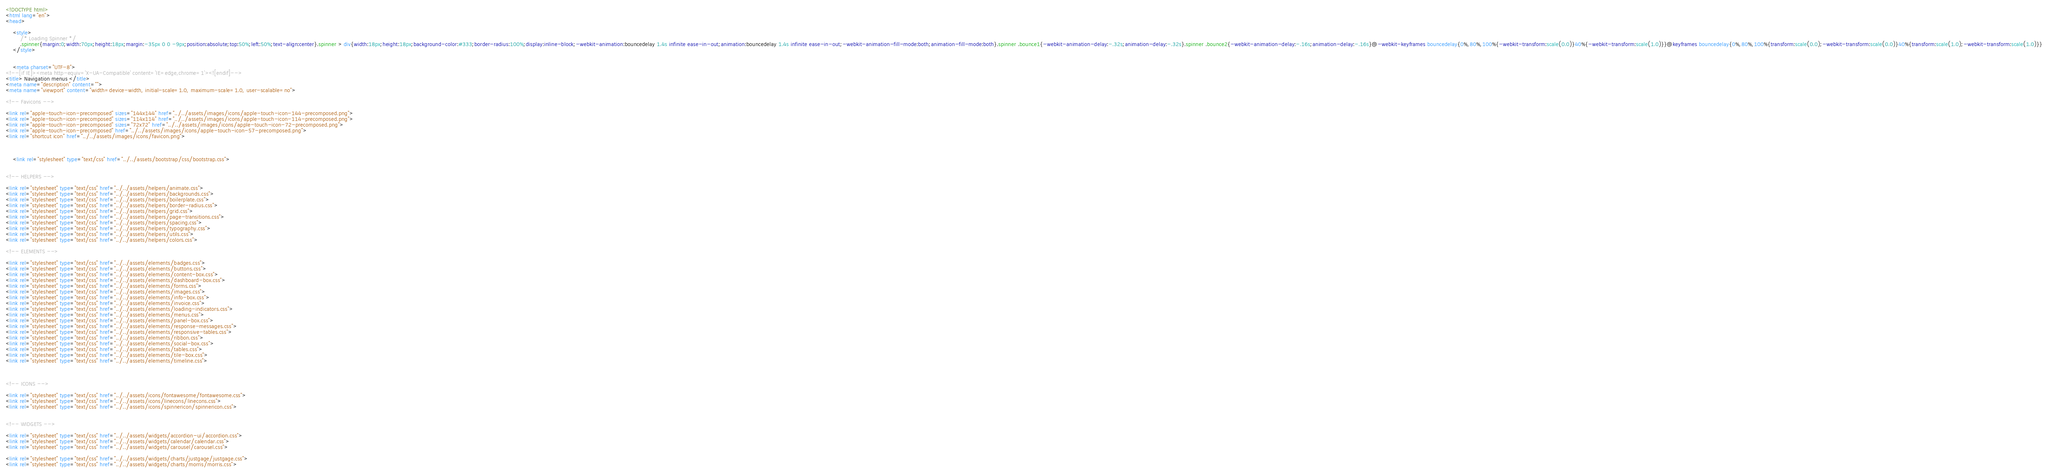<code> <loc_0><loc_0><loc_500><loc_500><_HTML_>
<!DOCTYPE html> 
<html lang="en">
<head>

    <style>
        /* Loading Spinner */
        .spinner{margin:0;width:70px;height:18px;margin:-35px 0 0 -9px;position:absolute;top:50%;left:50%;text-align:center}.spinner > div{width:18px;height:18px;background-color:#333;border-radius:100%;display:inline-block;-webkit-animation:bouncedelay 1.4s infinite ease-in-out;animation:bouncedelay 1.4s infinite ease-in-out;-webkit-animation-fill-mode:both;animation-fill-mode:both}.spinner .bounce1{-webkit-animation-delay:-.32s;animation-delay:-.32s}.spinner .bounce2{-webkit-animation-delay:-.16s;animation-delay:-.16s}@-webkit-keyframes bouncedelay{0%,80%,100%{-webkit-transform:scale(0.0)}40%{-webkit-transform:scale(1.0)}}@keyframes bouncedelay{0%,80%,100%{transform:scale(0.0);-webkit-transform:scale(0.0)}40%{transform:scale(1.0);-webkit-transform:scale(1.0)}}
    </style>


    <meta charset="UTF-8">
<!--[if IE]><meta http-equiv='X-UA-Compatible' content='IE=edge,chrome=1'><![endif]-->
<title> Navigation menus </title>
<meta name="description" content="">
<meta name="viewport" content="width=device-width, initial-scale=1.0, maximum-scale=1.0, user-scalable=no">

<!-- Favicons -->

<link rel="apple-touch-icon-precomposed" sizes="144x144" href="../../assets/images/icons/apple-touch-icon-144-precomposed.png">
<link rel="apple-touch-icon-precomposed" sizes="114x114" href="../../assets/images/icons/apple-touch-icon-114-precomposed.png">
<link rel="apple-touch-icon-precomposed" sizes="72x72" href="../../assets/images/icons/apple-touch-icon-72-precomposed.png">
<link rel="apple-touch-icon-precomposed" href="../../assets/images/icons/apple-touch-icon-57-precomposed.png">
<link rel="shortcut icon" href="../../assets/images/icons/favicon.png">



    <link rel="stylesheet" type="text/css" href="../../assets/bootstrap/css/bootstrap.css">


<!-- HELPERS -->

<link rel="stylesheet" type="text/css" href="../../assets/helpers/animate.css">
<link rel="stylesheet" type="text/css" href="../../assets/helpers/backgrounds.css">
<link rel="stylesheet" type="text/css" href="../../assets/helpers/boilerplate.css">
<link rel="stylesheet" type="text/css" href="../../assets/helpers/border-radius.css">
<link rel="stylesheet" type="text/css" href="../../assets/helpers/grid.css">
<link rel="stylesheet" type="text/css" href="../../assets/helpers/page-transitions.css">
<link rel="stylesheet" type="text/css" href="../../assets/helpers/spacing.css">
<link rel="stylesheet" type="text/css" href="../../assets/helpers/typography.css">
<link rel="stylesheet" type="text/css" href="../../assets/helpers/utils.css">
<link rel="stylesheet" type="text/css" href="../../assets/helpers/colors.css">

<!-- ELEMENTS -->

<link rel="stylesheet" type="text/css" href="../../assets/elements/badges.css">
<link rel="stylesheet" type="text/css" href="../../assets/elements/buttons.css">
<link rel="stylesheet" type="text/css" href="../../assets/elements/content-box.css">
<link rel="stylesheet" type="text/css" href="../../assets/elements/dashboard-box.css">
<link rel="stylesheet" type="text/css" href="../../assets/elements/forms.css">
<link rel="stylesheet" type="text/css" href="../../assets/elements/images.css">
<link rel="stylesheet" type="text/css" href="../../assets/elements/info-box.css">
<link rel="stylesheet" type="text/css" href="../../assets/elements/invoice.css">
<link rel="stylesheet" type="text/css" href="../../assets/elements/loading-indicators.css">
<link rel="stylesheet" type="text/css" href="../../assets/elements/menus.css">
<link rel="stylesheet" type="text/css" href="../../assets/elements/panel-box.css">
<link rel="stylesheet" type="text/css" href="../../assets/elements/response-messages.css">
<link rel="stylesheet" type="text/css" href="../../assets/elements/responsive-tables.css">
<link rel="stylesheet" type="text/css" href="../../assets/elements/ribbon.css">
<link rel="stylesheet" type="text/css" href="../../assets/elements/social-box.css">
<link rel="stylesheet" type="text/css" href="../../assets/elements/tables.css">
<link rel="stylesheet" type="text/css" href="../../assets/elements/tile-box.css">
<link rel="stylesheet" type="text/css" href="../../assets/elements/timeline.css">



<!-- ICONS -->

<link rel="stylesheet" type="text/css" href="../../assets/icons/fontawesome/fontawesome.css">
<link rel="stylesheet" type="text/css" href="../../assets/icons/linecons/linecons.css">
<link rel="stylesheet" type="text/css" href="../../assets/icons/spinnericon/spinnericon.css">


<!-- WIDGETS -->

<link rel="stylesheet" type="text/css" href="../../assets/widgets/accordion-ui/accordion.css">
<link rel="stylesheet" type="text/css" href="../../assets/widgets/calendar/calendar.css">
<link rel="stylesheet" type="text/css" href="../../assets/widgets/carousel/carousel.css">

<link rel="stylesheet" type="text/css" href="../../assets/widgets/charts/justgage/justgage.css">
<link rel="stylesheet" type="text/css" href="../../assets/widgets/charts/morris/morris.css"></code> 